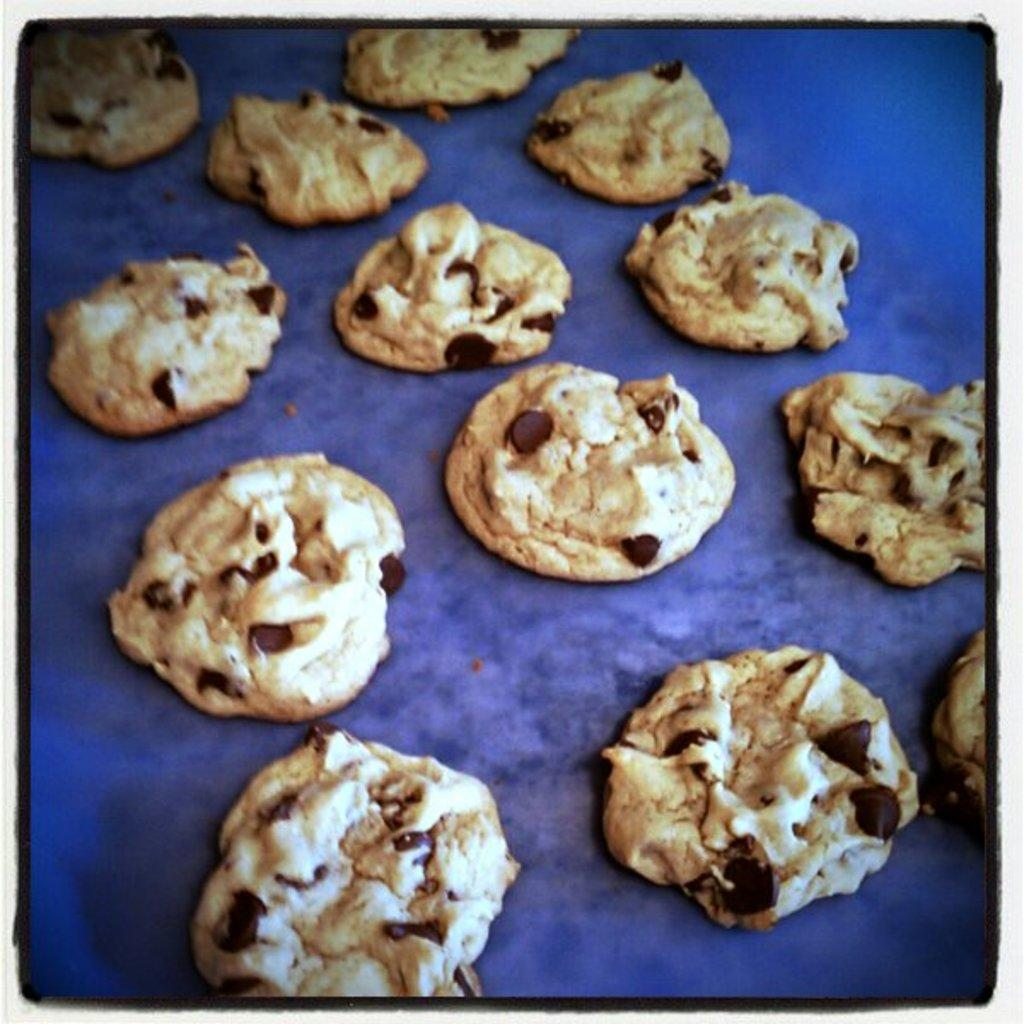What type of editing has been done to the image? The image is edited, but the specific type of editing is not mentioned in the facts. What type of food is present in the image? There are cookies in the image. What color is the surface on which the cookies are placed? The cookies are placed on a blue color surface. How many teeth can be seen in the image? There are no teeth visible in the image; it features cookies placed on a blue surface. What type of parcel is being delivered in the image? There is no parcel present in the image. 